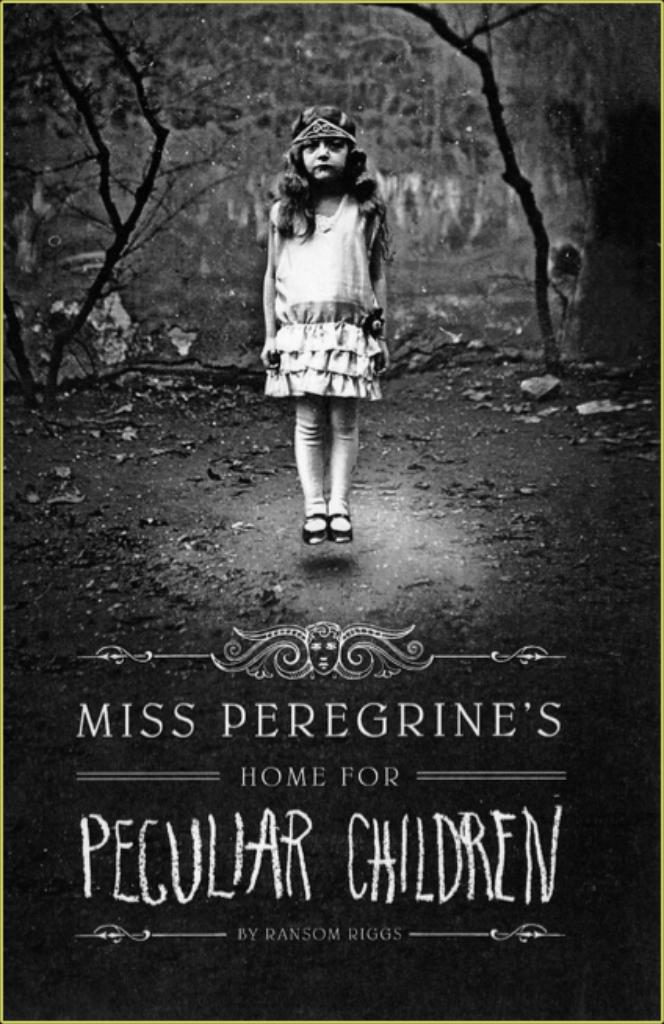Can you describe this image briefly? In this image there is a poster. In the poster there is a girl in the air, behind her there are trees and some dry leaves on the surface. At the bottom of the image there are some text and images. 